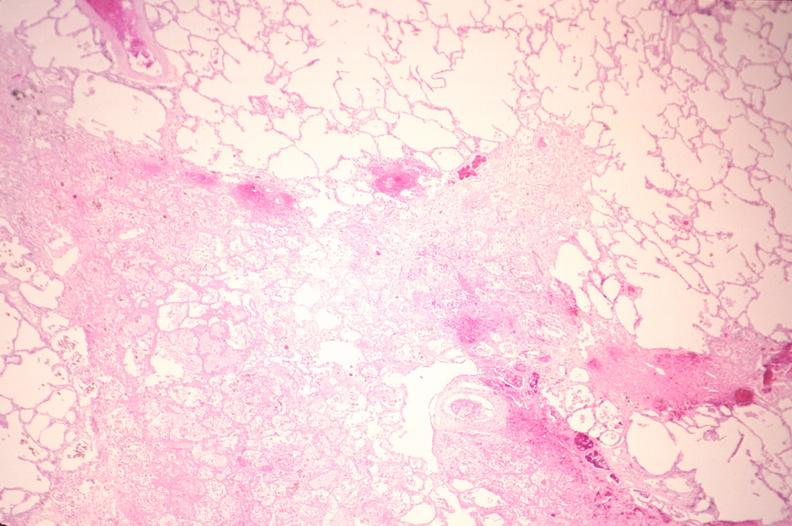what does this image show?
Answer the question using a single word or phrase. Lung 